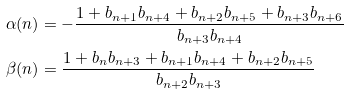<formula> <loc_0><loc_0><loc_500><loc_500>\alpha ( n ) & = - \frac { 1 + b _ { n + 1 } b _ { n + 4 } + b _ { n + 2 } b _ { n + 5 } + b _ { n + 3 } b _ { n + 6 } } { b _ { n + 3 } b _ { n + 4 } } \\ \beta ( n ) & = \frac { 1 + b _ { n } b _ { n + 3 } + b _ { n + 1 } b _ { n + 4 } + b _ { n + 2 } b _ { n + 5 } } { b _ { n + 2 } b _ { n + 3 } }</formula> 